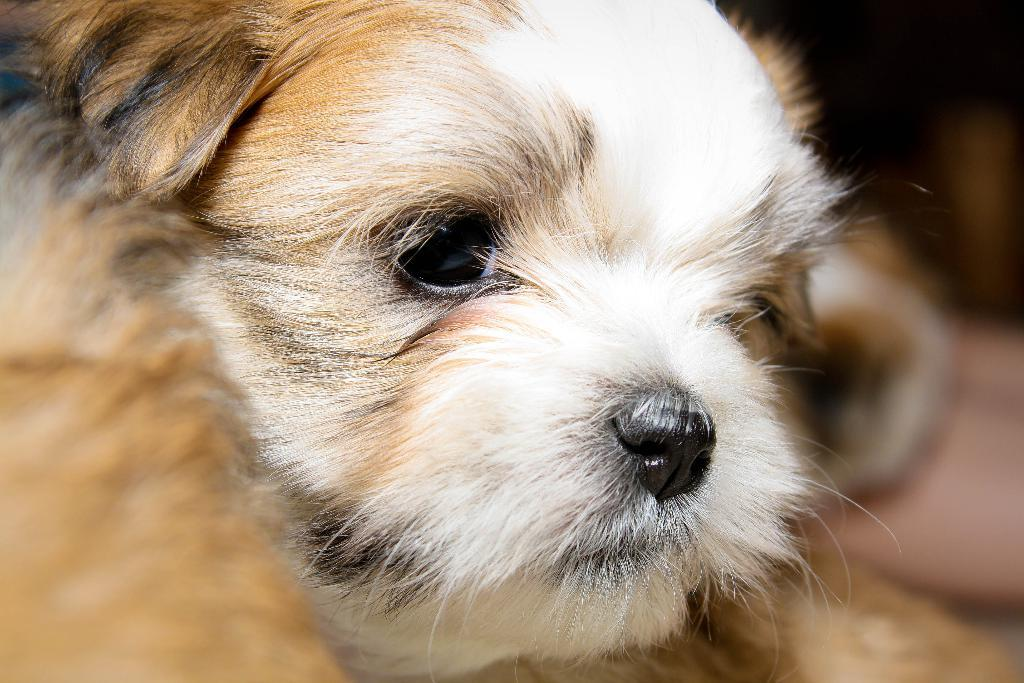What is the main subject of the image? The main subject of the image is a dog's face. Can you describe the color of the dog's face in the image? The dog's face is white and cream in color. What type of approval does the dog's face have in the image? There is no indication of approval or disapproval in the image; it simply shows a dog's face. What hobbies does the dog's face have in the image? The image only shows a dog's face, and there is no information about the dog's hobbies. 